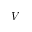Convert formula to latex. <formula><loc_0><loc_0><loc_500><loc_500>V</formula> 